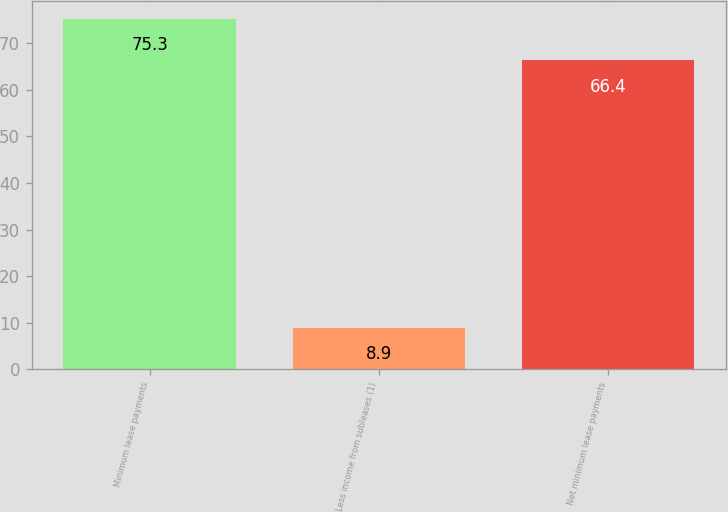Convert chart. <chart><loc_0><loc_0><loc_500><loc_500><bar_chart><fcel>Minimum lease payments<fcel>Less income from subleases (1)<fcel>Net minimum lease payments<nl><fcel>75.3<fcel>8.9<fcel>66.4<nl></chart> 